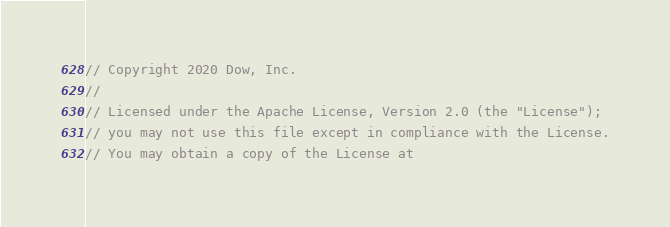<code> <loc_0><loc_0><loc_500><loc_500><_C++_>// Copyright 2020 Dow, Inc.
//
// Licensed under the Apache License, Version 2.0 (the "License");
// you may not use this file except in compliance with the License.
// You may obtain a copy of the License at</code> 